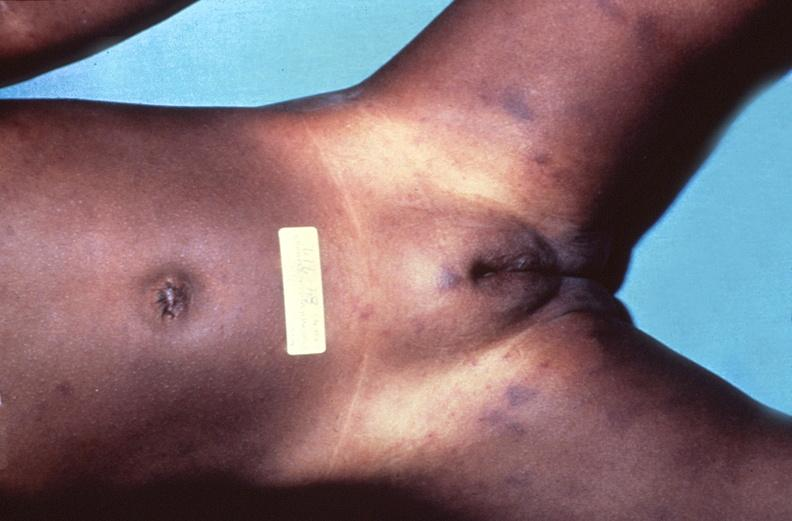does spleen show meningococcemia, petechia?
Answer the question using a single word or phrase. No 